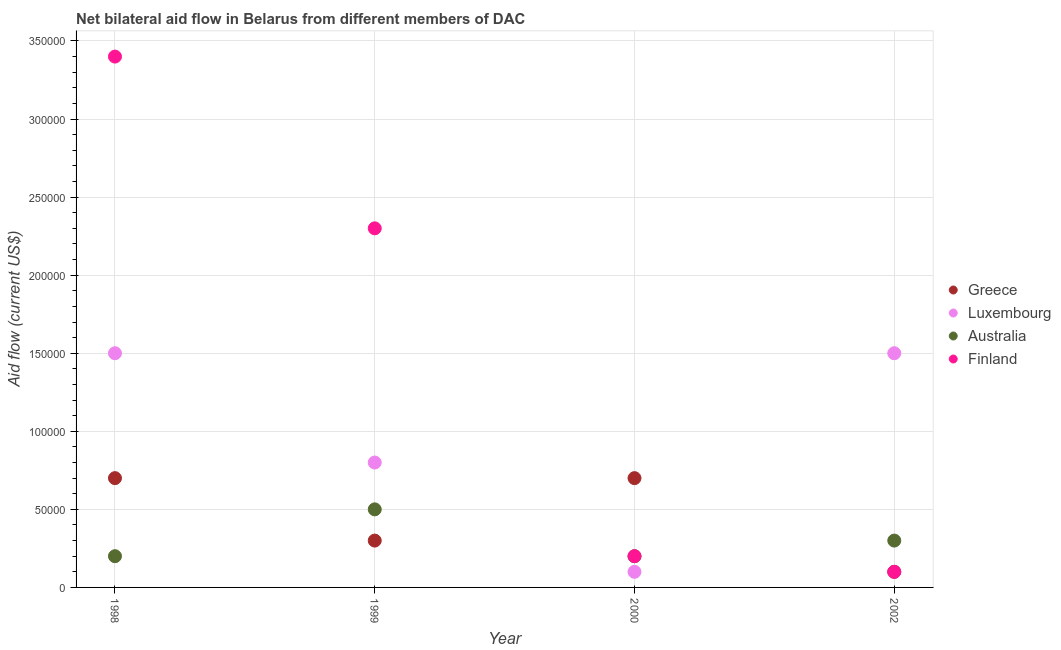Is the number of dotlines equal to the number of legend labels?
Provide a succinct answer. Yes. What is the amount of aid given by luxembourg in 2002?
Your response must be concise. 1.50e+05. Across all years, what is the maximum amount of aid given by finland?
Your answer should be compact. 3.40e+05. Across all years, what is the minimum amount of aid given by finland?
Make the answer very short. 10000. In which year was the amount of aid given by australia maximum?
Make the answer very short. 1999. What is the total amount of aid given by greece in the graph?
Offer a terse response. 1.80e+05. What is the difference between the amount of aid given by australia in 1999 and that in 2002?
Ensure brevity in your answer.  2.00e+04. What is the difference between the amount of aid given by australia in 2002 and the amount of aid given by finland in 2000?
Provide a succinct answer. 10000. What is the average amount of aid given by luxembourg per year?
Make the answer very short. 9.75e+04. In the year 1998, what is the difference between the amount of aid given by luxembourg and amount of aid given by australia?
Offer a terse response. 1.30e+05. What is the ratio of the amount of aid given by luxembourg in 1998 to that in 1999?
Your answer should be very brief. 1.88. Is the difference between the amount of aid given by luxembourg in 1998 and 2000 greater than the difference between the amount of aid given by finland in 1998 and 2000?
Provide a succinct answer. No. What is the difference between the highest and the second highest amount of aid given by luxembourg?
Offer a very short reply. 0. What is the difference between the highest and the lowest amount of aid given by luxembourg?
Offer a very short reply. 1.40e+05. In how many years, is the amount of aid given by luxembourg greater than the average amount of aid given by luxembourg taken over all years?
Your answer should be very brief. 2. How many dotlines are there?
Your answer should be very brief. 4. Are the values on the major ticks of Y-axis written in scientific E-notation?
Your response must be concise. No. Does the graph contain grids?
Provide a succinct answer. Yes. How are the legend labels stacked?
Ensure brevity in your answer.  Vertical. What is the title of the graph?
Give a very brief answer. Net bilateral aid flow in Belarus from different members of DAC. Does "Secondary vocational education" appear as one of the legend labels in the graph?
Ensure brevity in your answer.  No. What is the Aid flow (current US$) of Greece in 1998?
Offer a terse response. 7.00e+04. What is the Aid flow (current US$) of Luxembourg in 1998?
Offer a very short reply. 1.50e+05. What is the Aid flow (current US$) of Australia in 1998?
Offer a very short reply. 2.00e+04. What is the Aid flow (current US$) in Greece in 1999?
Your answer should be compact. 3.00e+04. What is the Aid flow (current US$) of Australia in 1999?
Ensure brevity in your answer.  5.00e+04. What is the Aid flow (current US$) in Greece in 2000?
Offer a very short reply. 7.00e+04. What is the Aid flow (current US$) in Luxembourg in 2000?
Your answer should be very brief. 10000. What is the Aid flow (current US$) in Australia in 2000?
Ensure brevity in your answer.  2.00e+04. What is the Aid flow (current US$) of Greece in 2002?
Make the answer very short. 10000. What is the Aid flow (current US$) in Australia in 2002?
Offer a very short reply. 3.00e+04. What is the Aid flow (current US$) of Finland in 2002?
Offer a very short reply. 10000. Across all years, what is the maximum Aid flow (current US$) in Australia?
Give a very brief answer. 5.00e+04. Across all years, what is the maximum Aid flow (current US$) in Finland?
Your answer should be compact. 3.40e+05. Across all years, what is the minimum Aid flow (current US$) in Greece?
Give a very brief answer. 10000. Across all years, what is the minimum Aid flow (current US$) of Luxembourg?
Your answer should be compact. 10000. Across all years, what is the minimum Aid flow (current US$) of Australia?
Your response must be concise. 2.00e+04. What is the total Aid flow (current US$) of Greece in the graph?
Make the answer very short. 1.80e+05. What is the total Aid flow (current US$) of Luxembourg in the graph?
Provide a succinct answer. 3.90e+05. What is the total Aid flow (current US$) of Finland in the graph?
Your answer should be very brief. 6.00e+05. What is the difference between the Aid flow (current US$) of Greece in 1998 and that in 1999?
Offer a terse response. 4.00e+04. What is the difference between the Aid flow (current US$) in Luxembourg in 1998 and that in 1999?
Provide a succinct answer. 7.00e+04. What is the difference between the Aid flow (current US$) in Finland in 1998 and that in 1999?
Ensure brevity in your answer.  1.10e+05. What is the difference between the Aid flow (current US$) in Finland in 1998 and that in 2000?
Your answer should be very brief. 3.20e+05. What is the difference between the Aid flow (current US$) in Luxembourg in 1999 and that in 2000?
Offer a very short reply. 7.00e+04. What is the difference between the Aid flow (current US$) of Finland in 1999 and that in 2000?
Make the answer very short. 2.10e+05. What is the difference between the Aid flow (current US$) of Australia in 1999 and that in 2002?
Offer a terse response. 2.00e+04. What is the difference between the Aid flow (current US$) of Finland in 1999 and that in 2002?
Offer a very short reply. 2.20e+05. What is the difference between the Aid flow (current US$) in Greece in 2000 and that in 2002?
Your response must be concise. 6.00e+04. What is the difference between the Aid flow (current US$) in Luxembourg in 2000 and that in 2002?
Your answer should be very brief. -1.40e+05. What is the difference between the Aid flow (current US$) in Australia in 2000 and that in 2002?
Make the answer very short. -10000. What is the difference between the Aid flow (current US$) in Greece in 1998 and the Aid flow (current US$) in Luxembourg in 1999?
Your answer should be compact. -10000. What is the difference between the Aid flow (current US$) in Greece in 1998 and the Aid flow (current US$) in Australia in 1999?
Your answer should be very brief. 2.00e+04. What is the difference between the Aid flow (current US$) of Australia in 1998 and the Aid flow (current US$) of Finland in 1999?
Make the answer very short. -2.10e+05. What is the difference between the Aid flow (current US$) of Greece in 1998 and the Aid flow (current US$) of Luxembourg in 2000?
Your response must be concise. 6.00e+04. What is the difference between the Aid flow (current US$) in Luxembourg in 1998 and the Aid flow (current US$) in Finland in 2000?
Offer a very short reply. 1.30e+05. What is the difference between the Aid flow (current US$) in Australia in 1998 and the Aid flow (current US$) in Finland in 2000?
Make the answer very short. 0. What is the difference between the Aid flow (current US$) of Greece in 1998 and the Aid flow (current US$) of Australia in 2002?
Provide a short and direct response. 4.00e+04. What is the difference between the Aid flow (current US$) in Greece in 1998 and the Aid flow (current US$) in Finland in 2002?
Your answer should be compact. 6.00e+04. What is the difference between the Aid flow (current US$) of Luxembourg in 1998 and the Aid flow (current US$) of Finland in 2002?
Give a very brief answer. 1.40e+05. What is the difference between the Aid flow (current US$) in Greece in 1999 and the Aid flow (current US$) in Luxembourg in 2000?
Provide a short and direct response. 2.00e+04. What is the difference between the Aid flow (current US$) of Greece in 1999 and the Aid flow (current US$) of Australia in 2000?
Your answer should be compact. 10000. What is the difference between the Aid flow (current US$) of Greece in 1999 and the Aid flow (current US$) of Finland in 2000?
Keep it short and to the point. 10000. What is the difference between the Aid flow (current US$) in Luxembourg in 1999 and the Aid flow (current US$) in Finland in 2000?
Your answer should be compact. 6.00e+04. What is the difference between the Aid flow (current US$) in Australia in 1999 and the Aid flow (current US$) in Finland in 2000?
Offer a terse response. 3.00e+04. What is the difference between the Aid flow (current US$) in Greece in 1999 and the Aid flow (current US$) in Luxembourg in 2002?
Offer a terse response. -1.20e+05. What is the difference between the Aid flow (current US$) in Australia in 1999 and the Aid flow (current US$) in Finland in 2002?
Your answer should be compact. 4.00e+04. What is the difference between the Aid flow (current US$) of Greece in 2000 and the Aid flow (current US$) of Luxembourg in 2002?
Give a very brief answer. -8.00e+04. What is the difference between the Aid flow (current US$) in Greece in 2000 and the Aid flow (current US$) in Finland in 2002?
Offer a very short reply. 6.00e+04. What is the difference between the Aid flow (current US$) of Luxembourg in 2000 and the Aid flow (current US$) of Australia in 2002?
Your answer should be compact. -2.00e+04. What is the difference between the Aid flow (current US$) in Luxembourg in 2000 and the Aid flow (current US$) in Finland in 2002?
Offer a terse response. 0. What is the average Aid flow (current US$) in Greece per year?
Your response must be concise. 4.50e+04. What is the average Aid flow (current US$) of Luxembourg per year?
Make the answer very short. 9.75e+04. What is the average Aid flow (current US$) in Australia per year?
Offer a very short reply. 3.00e+04. In the year 1998, what is the difference between the Aid flow (current US$) in Greece and Aid flow (current US$) in Luxembourg?
Give a very brief answer. -8.00e+04. In the year 1998, what is the difference between the Aid flow (current US$) in Greece and Aid flow (current US$) in Finland?
Your response must be concise. -2.70e+05. In the year 1998, what is the difference between the Aid flow (current US$) of Luxembourg and Aid flow (current US$) of Australia?
Your response must be concise. 1.30e+05. In the year 1998, what is the difference between the Aid flow (current US$) in Australia and Aid flow (current US$) in Finland?
Provide a succinct answer. -3.20e+05. In the year 1999, what is the difference between the Aid flow (current US$) in Greece and Aid flow (current US$) in Luxembourg?
Ensure brevity in your answer.  -5.00e+04. In the year 1999, what is the difference between the Aid flow (current US$) of Greece and Aid flow (current US$) of Finland?
Provide a short and direct response. -2.00e+05. In the year 1999, what is the difference between the Aid flow (current US$) of Luxembourg and Aid flow (current US$) of Australia?
Ensure brevity in your answer.  3.00e+04. In the year 1999, what is the difference between the Aid flow (current US$) in Luxembourg and Aid flow (current US$) in Finland?
Offer a very short reply. -1.50e+05. In the year 1999, what is the difference between the Aid flow (current US$) in Australia and Aid flow (current US$) in Finland?
Provide a short and direct response. -1.80e+05. In the year 2000, what is the difference between the Aid flow (current US$) in Greece and Aid flow (current US$) in Luxembourg?
Provide a succinct answer. 6.00e+04. In the year 2000, what is the difference between the Aid flow (current US$) of Luxembourg and Aid flow (current US$) of Australia?
Give a very brief answer. -10000. In the year 2000, what is the difference between the Aid flow (current US$) of Luxembourg and Aid flow (current US$) of Finland?
Offer a terse response. -10000. In the year 2000, what is the difference between the Aid flow (current US$) of Australia and Aid flow (current US$) of Finland?
Provide a succinct answer. 0. In the year 2002, what is the difference between the Aid flow (current US$) of Greece and Aid flow (current US$) of Luxembourg?
Your answer should be compact. -1.40e+05. In the year 2002, what is the difference between the Aid flow (current US$) in Greece and Aid flow (current US$) in Finland?
Ensure brevity in your answer.  0. In the year 2002, what is the difference between the Aid flow (current US$) in Luxembourg and Aid flow (current US$) in Australia?
Your answer should be compact. 1.20e+05. In the year 2002, what is the difference between the Aid flow (current US$) in Luxembourg and Aid flow (current US$) in Finland?
Keep it short and to the point. 1.40e+05. What is the ratio of the Aid flow (current US$) in Greece in 1998 to that in 1999?
Make the answer very short. 2.33. What is the ratio of the Aid flow (current US$) of Luxembourg in 1998 to that in 1999?
Your answer should be very brief. 1.88. What is the ratio of the Aid flow (current US$) of Finland in 1998 to that in 1999?
Your answer should be compact. 1.48. What is the ratio of the Aid flow (current US$) in Australia in 1998 to that in 2000?
Provide a short and direct response. 1. What is the ratio of the Aid flow (current US$) of Greece in 1998 to that in 2002?
Your response must be concise. 7. What is the ratio of the Aid flow (current US$) in Australia in 1998 to that in 2002?
Your answer should be very brief. 0.67. What is the ratio of the Aid flow (current US$) of Greece in 1999 to that in 2000?
Keep it short and to the point. 0.43. What is the ratio of the Aid flow (current US$) in Luxembourg in 1999 to that in 2000?
Your answer should be compact. 8. What is the ratio of the Aid flow (current US$) in Finland in 1999 to that in 2000?
Provide a short and direct response. 11.5. What is the ratio of the Aid flow (current US$) of Luxembourg in 1999 to that in 2002?
Give a very brief answer. 0.53. What is the ratio of the Aid flow (current US$) of Greece in 2000 to that in 2002?
Your answer should be very brief. 7. What is the ratio of the Aid flow (current US$) in Luxembourg in 2000 to that in 2002?
Keep it short and to the point. 0.07. What is the ratio of the Aid flow (current US$) of Australia in 2000 to that in 2002?
Offer a very short reply. 0.67. What is the ratio of the Aid flow (current US$) of Finland in 2000 to that in 2002?
Give a very brief answer. 2. What is the difference between the highest and the second highest Aid flow (current US$) in Greece?
Your answer should be compact. 0. What is the difference between the highest and the second highest Aid flow (current US$) of Australia?
Your answer should be compact. 2.00e+04. What is the difference between the highest and the lowest Aid flow (current US$) in Finland?
Offer a very short reply. 3.30e+05. 